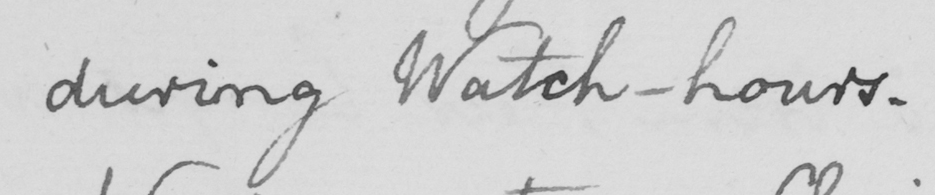Transcribe the text shown in this historical manuscript line. during Watch-hours . 